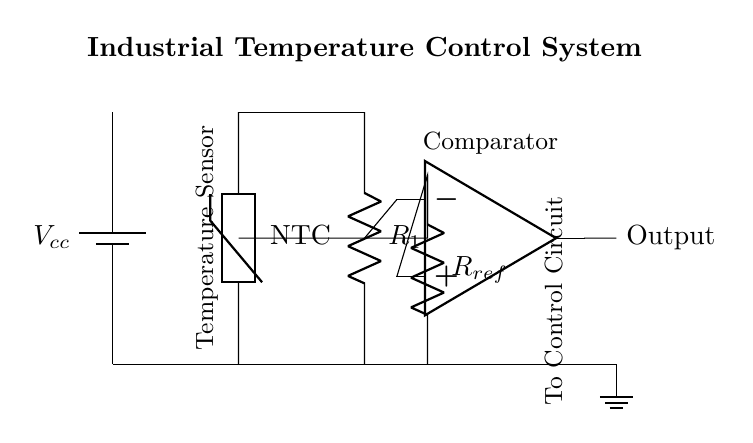What is the primary function of the NTC thermistor? The NTC thermistor functions as a temperature sensor; its resistance decreases with an increase in temperature, enabling it to monitor temperature changes.
Answer: Temperature sensor What type of operational amplifier configuration is used here? The operational amplifier in the diagram functions primarily as a comparator, comparing the voltage from the thermistor to the reference voltage.
Answer: Comparator What is the purpose of the resistor labeled R_subscript_1? Resistor R1 operates in conjunction with the thermistor to form a voltage divider, allowing the output voltage of the circuit to vary based on the temperature sensed by the NTC thermistor.
Answer: Voltage divider How does the reference voltage affect the output? The reference voltage determines the threshold at which the op-amp switches states, impacting the output signal that activates the control circuit based on temperature readings from the thermistor.
Answer: Threshold for switching What is the role of the output connection from the op-amp? The output from the op-amp sends the processed signal to the control circuit, which can adjust operational parameters based on the temperature readings.
Answer: To control circuit 